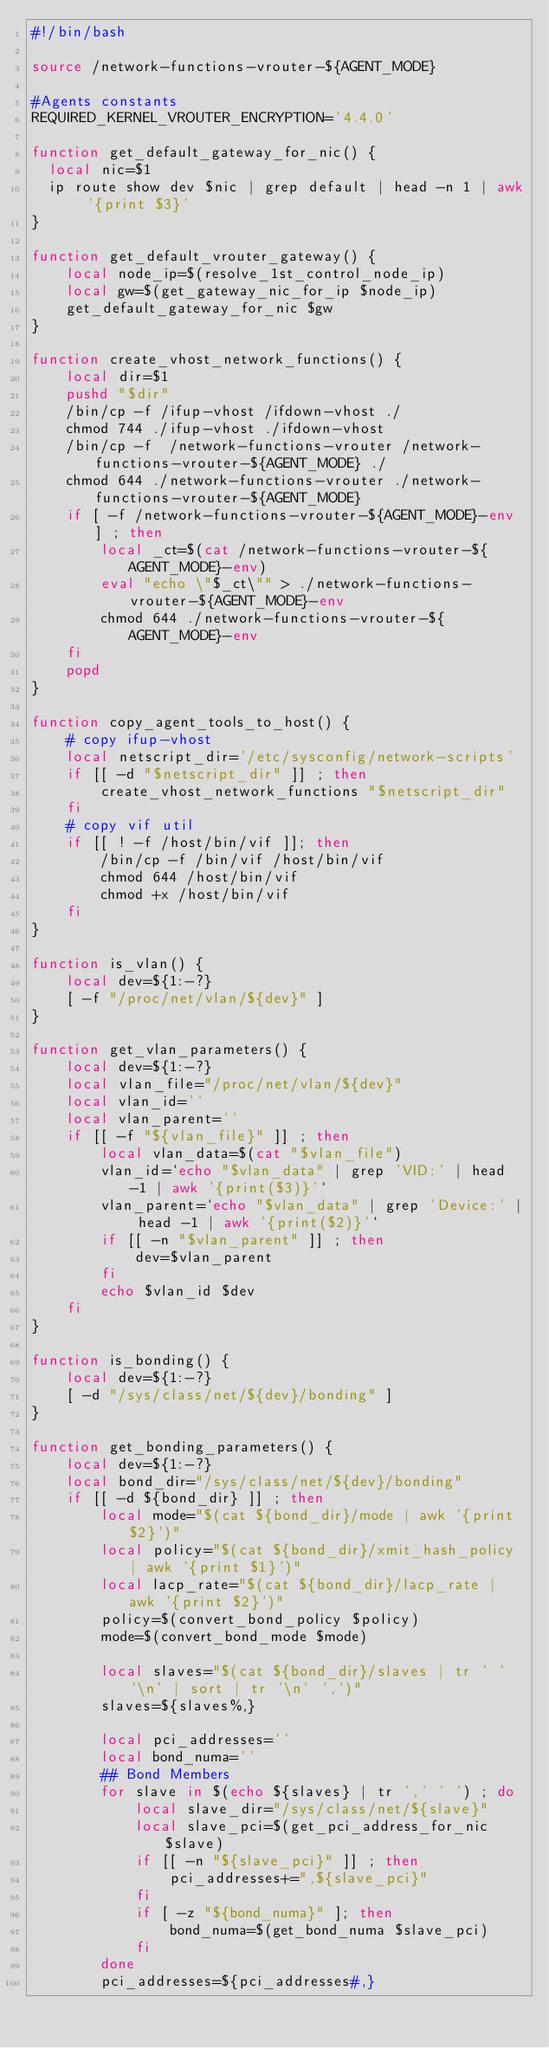Convert code to text. <code><loc_0><loc_0><loc_500><loc_500><_Bash_>#!/bin/bash

source /network-functions-vrouter-${AGENT_MODE}

#Agents constants
REQUIRED_KERNEL_VROUTER_ENCRYPTION='4.4.0'

function get_default_gateway_for_nic() {
  local nic=$1
  ip route show dev $nic | grep default | head -n 1 | awk '{print $3}'
}

function get_default_vrouter_gateway() {
    local node_ip=$(resolve_1st_control_node_ip)
    local gw=$(get_gateway_nic_for_ip $node_ip)
    get_default_gateway_for_nic $gw
}

function create_vhost_network_functions() {
    local dir=$1
    pushd "$dir"
    /bin/cp -f /ifup-vhost /ifdown-vhost ./
    chmod 744 ./ifup-vhost ./ifdown-vhost
    /bin/cp -f  /network-functions-vrouter /network-functions-vrouter-${AGENT_MODE} ./
    chmod 644 ./network-functions-vrouter ./network-functions-vrouter-${AGENT_MODE}
    if [ -f /network-functions-vrouter-${AGENT_MODE}-env ] ; then
        local _ct=$(cat /network-functions-vrouter-${AGENT_MODE}-env)
        eval "echo \"$_ct\"" > ./network-functions-vrouter-${AGENT_MODE}-env
        chmod 644 ./network-functions-vrouter-${AGENT_MODE}-env
    fi
    popd
}

function copy_agent_tools_to_host() {
    # copy ifup-vhost
    local netscript_dir='/etc/sysconfig/network-scripts'
    if [[ -d "$netscript_dir" ]] ; then
        create_vhost_network_functions "$netscript_dir"
    fi
    # copy vif util
    if [[ ! -f /host/bin/vif ]]; then
        /bin/cp -f /bin/vif /host/bin/vif
        chmod 644 /host/bin/vif
        chmod +x /host/bin/vif
    fi
}

function is_vlan() {
    local dev=${1:-?}
    [ -f "/proc/net/vlan/${dev}" ]
}

function get_vlan_parameters() {
    local dev=${1:-?}
    local vlan_file="/proc/net/vlan/${dev}"
    local vlan_id=''
    local vlan_parent=''
    if [[ -f "${vlan_file}" ]] ; then
        local vlan_data=$(cat "$vlan_file")
        vlan_id=`echo "$vlan_data" | grep 'VID:' | head -1 | awk '{print($3)}'`
        vlan_parent=`echo "$vlan_data" | grep 'Device:' | head -1 | awk '{print($2)}'`
        if [[ -n "$vlan_parent" ]] ; then
            dev=$vlan_parent
        fi
        echo $vlan_id $dev
    fi
}

function is_bonding() {
    local dev=${1:-?}
    [ -d "/sys/class/net/${dev}/bonding" ]
}

function get_bonding_parameters() {
    local dev=${1:-?}
    local bond_dir="/sys/class/net/${dev}/bonding"
    if [[ -d ${bond_dir} ]] ; then
        local mode="$(cat ${bond_dir}/mode | awk '{print $2}')"
        local policy="$(cat ${bond_dir}/xmit_hash_policy | awk '{print $1}')"
        local lacp_rate="$(cat ${bond_dir}/lacp_rate | awk '{print $2}')"
        policy=$(convert_bond_policy $policy)
        mode=$(convert_bond_mode $mode)

        local slaves="$(cat ${bond_dir}/slaves | tr ' ' '\n' | sort | tr '\n' ',')"
        slaves=${slaves%,}

        local pci_addresses=''
        local bond_numa=''
        ## Bond Members
        for slave in $(echo ${slaves} | tr ',' ' ') ; do
            local slave_dir="/sys/class/net/${slave}"
            local slave_pci=$(get_pci_address_for_nic $slave)
            if [[ -n "${slave_pci}" ]] ; then
                pci_addresses+=",${slave_pci}"
            fi
            if [ -z "${bond_numa}" ]; then
                bond_numa=$(get_bond_numa $slave_pci)
            fi
        done
        pci_addresses=${pci_addresses#,}
</code> 